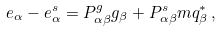Convert formula to latex. <formula><loc_0><loc_0><loc_500><loc_500>e _ { \alpha } - e _ { \alpha } ^ { s } = P _ { \alpha \beta } ^ { g } g _ { \beta } + P _ { \alpha \beta } ^ { s } m q _ { \beta } ^ { * } \, ,</formula> 